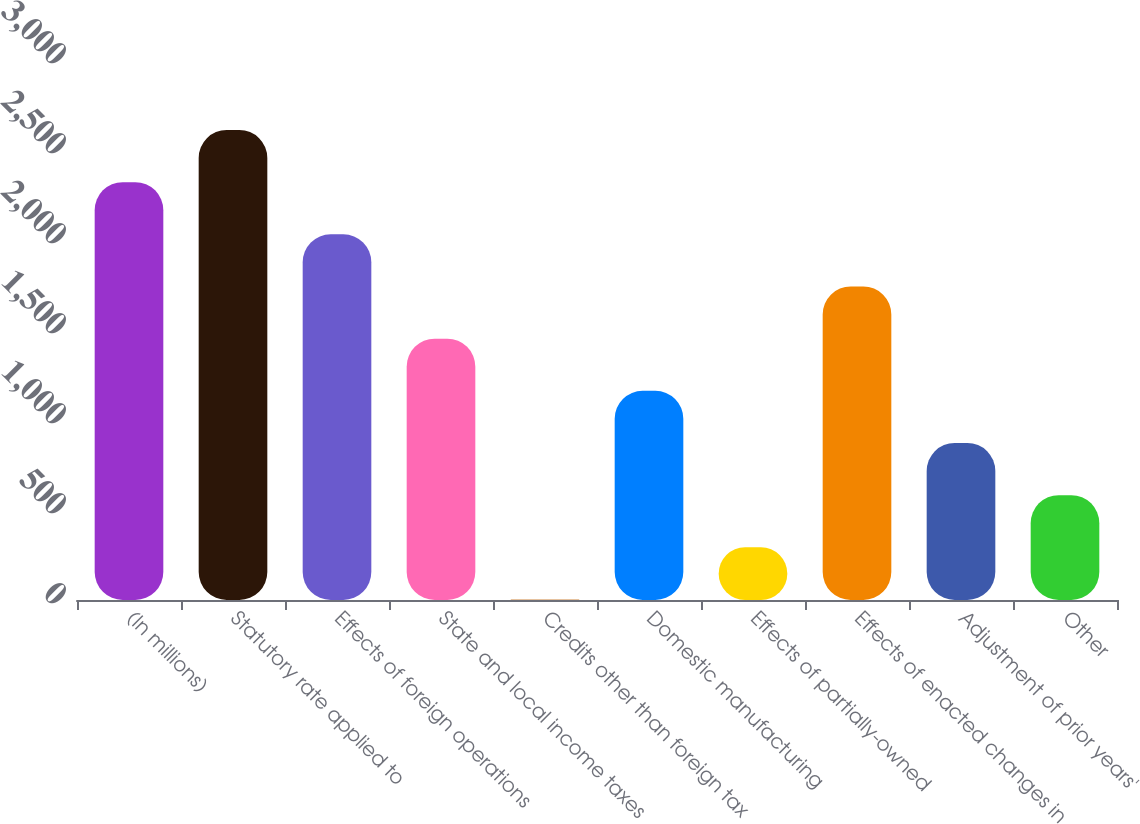Convert chart to OTSL. <chart><loc_0><loc_0><loc_500><loc_500><bar_chart><fcel>(In millions)<fcel>Statutory rate applied to<fcel>Effects of foreign operations<fcel>State and local income taxes<fcel>Credits other than foreign tax<fcel>Domestic manufacturing<fcel>Effects of partially-owned<fcel>Effects of enacted changes in<fcel>Adjustment of prior years'<fcel>Other<nl><fcel>2321.4<fcel>2611.2<fcel>2031.6<fcel>1452<fcel>3<fcel>1162.2<fcel>292.8<fcel>1741.8<fcel>872.4<fcel>582.6<nl></chart> 